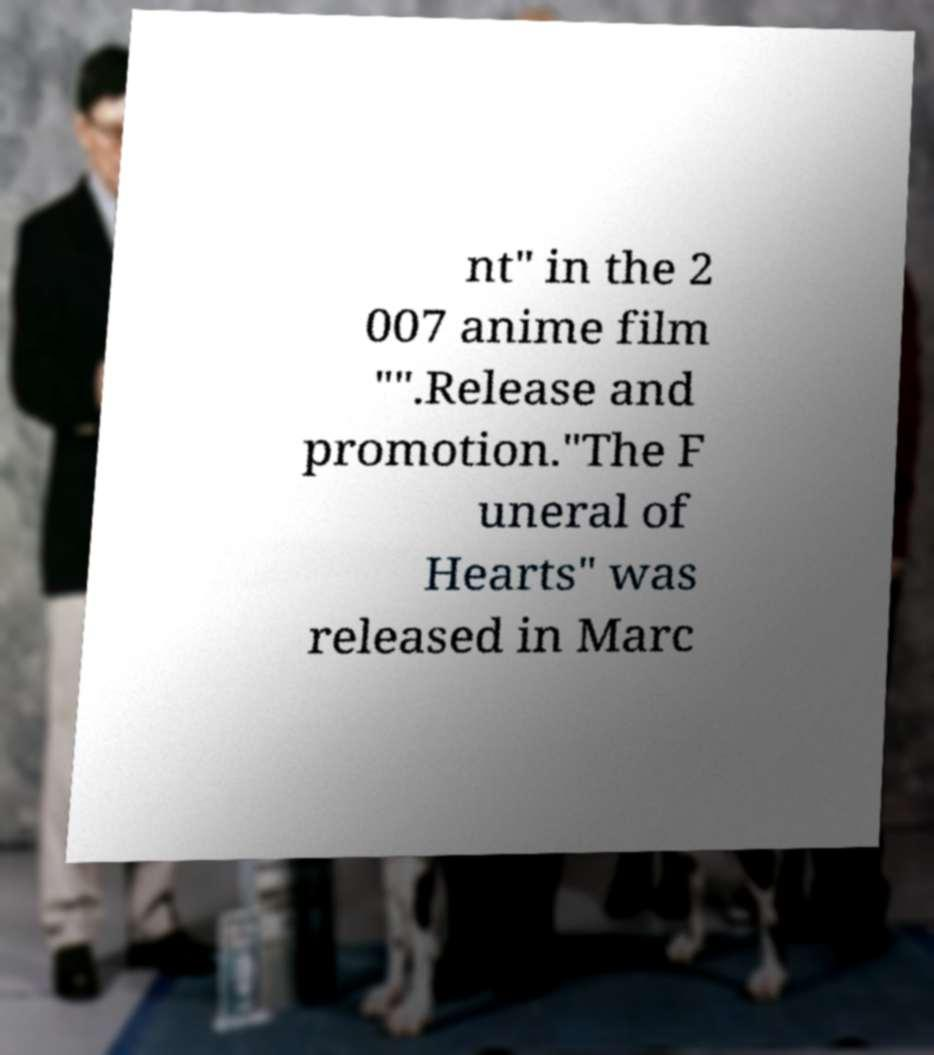There's text embedded in this image that I need extracted. Can you transcribe it verbatim? nt" in the 2 007 anime film "".Release and promotion."The F uneral of Hearts" was released in Marc 